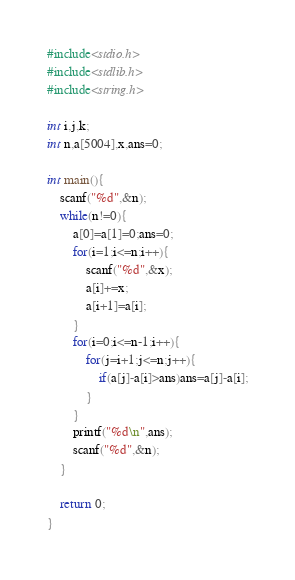Convert code to text. <code><loc_0><loc_0><loc_500><loc_500><_C_>#include<stdio.h>
#include<stdlib.h>
#include<string.h>

int i,j,k;
int n,a[5004],x,ans=0;

int main(){
	scanf("%d",&n);
	while(n!=0){
		a[0]=a[1]=0;ans=0;
		for(i=1;i<=n;i++){
			scanf("%d",&x);
			a[i]+=x;
			a[i+1]=a[i];
		}
		for(i=0;i<=n-1;i++){
			for(j=i+1;j<=n;j++){
				if(a[j]-a[i]>ans)ans=a[j]-a[i];
			}
		}
		printf("%d\n",ans);
		scanf("%d",&n);
	}
	
	return 0;
}</code> 